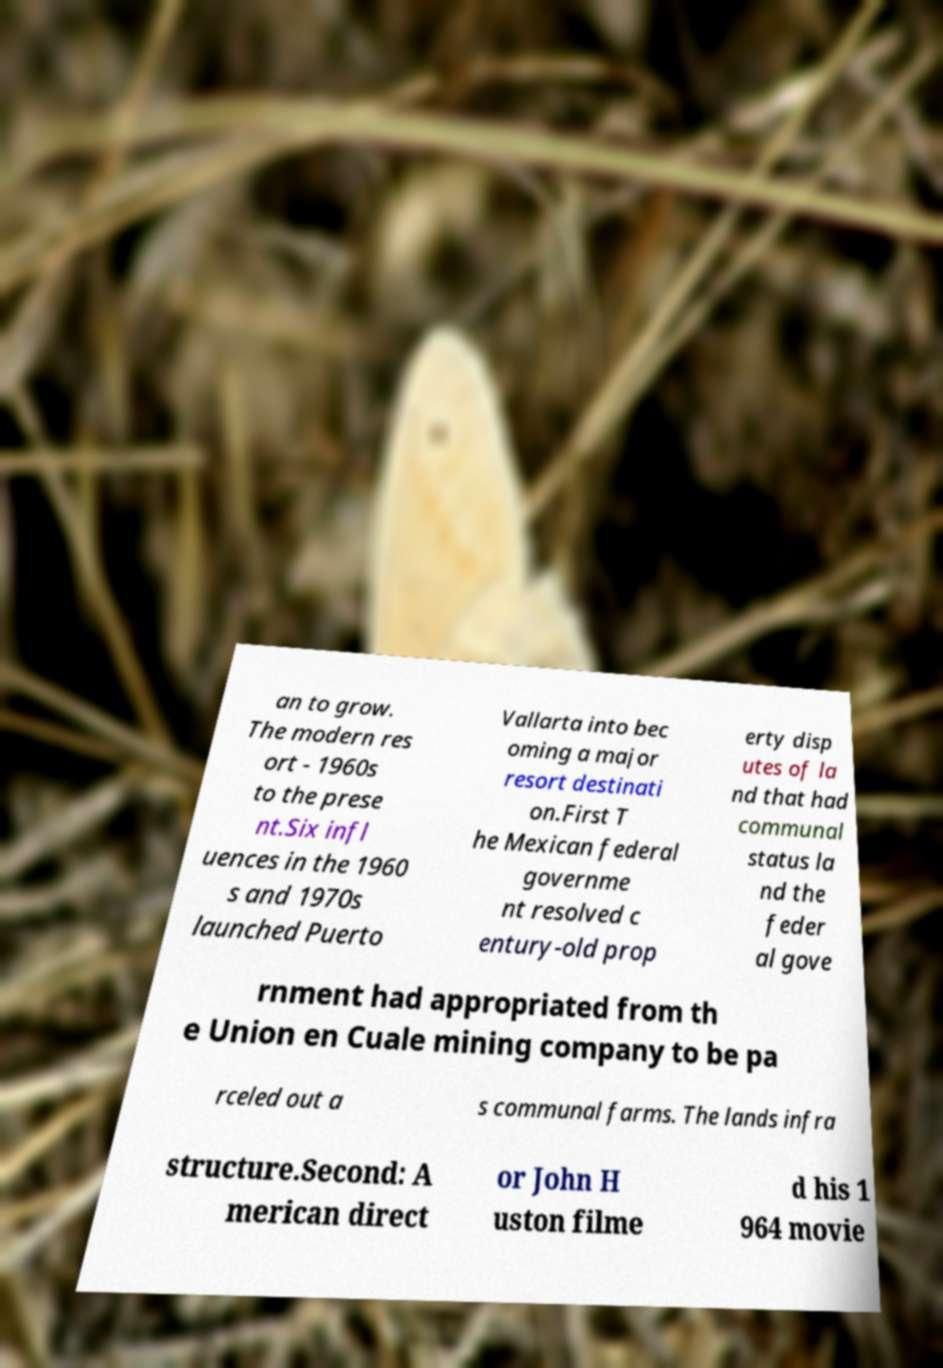What messages or text are displayed in this image? I need them in a readable, typed format. an to grow. The modern res ort - 1960s to the prese nt.Six infl uences in the 1960 s and 1970s launched Puerto Vallarta into bec oming a major resort destinati on.First T he Mexican federal governme nt resolved c entury-old prop erty disp utes of la nd that had communal status la nd the feder al gove rnment had appropriated from th e Union en Cuale mining company to be pa rceled out a s communal farms. The lands infra structure.Second: A merican direct or John H uston filme d his 1 964 movie 